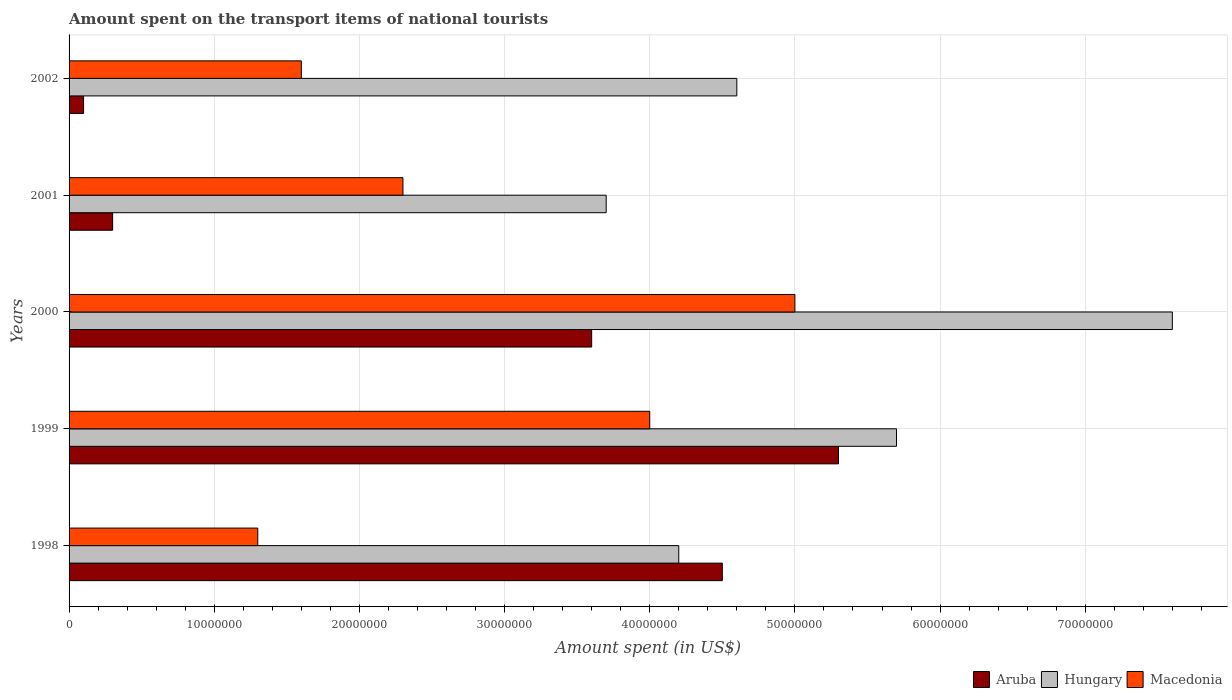How many bars are there on the 3rd tick from the top?
Your response must be concise. 3. How many bars are there on the 4th tick from the bottom?
Your answer should be compact. 3. What is the label of the 1st group of bars from the top?
Offer a terse response. 2002. In how many cases, is the number of bars for a given year not equal to the number of legend labels?
Offer a very short reply. 0. What is the amount spent on the transport items of national tourists in Macedonia in 1998?
Offer a very short reply. 1.30e+07. In which year was the amount spent on the transport items of national tourists in Aruba maximum?
Your response must be concise. 1999. What is the total amount spent on the transport items of national tourists in Aruba in the graph?
Offer a terse response. 1.38e+08. What is the average amount spent on the transport items of national tourists in Hungary per year?
Your answer should be compact. 5.16e+07. In the year 2001, what is the difference between the amount spent on the transport items of national tourists in Aruba and amount spent on the transport items of national tourists in Hungary?
Keep it short and to the point. -3.40e+07. In how many years, is the amount spent on the transport items of national tourists in Aruba greater than 52000000 US$?
Your answer should be very brief. 1. What is the ratio of the amount spent on the transport items of national tourists in Hungary in 1999 to that in 2000?
Offer a terse response. 0.75. Is the difference between the amount spent on the transport items of national tourists in Aruba in 1998 and 2001 greater than the difference between the amount spent on the transport items of national tourists in Hungary in 1998 and 2001?
Provide a short and direct response. Yes. What is the difference between the highest and the lowest amount spent on the transport items of national tourists in Hungary?
Your answer should be compact. 3.90e+07. In how many years, is the amount spent on the transport items of national tourists in Hungary greater than the average amount spent on the transport items of national tourists in Hungary taken over all years?
Make the answer very short. 2. Is the sum of the amount spent on the transport items of national tourists in Macedonia in 1998 and 2000 greater than the maximum amount spent on the transport items of national tourists in Aruba across all years?
Offer a very short reply. Yes. What does the 3rd bar from the top in 2001 represents?
Your answer should be very brief. Aruba. What does the 1st bar from the bottom in 2002 represents?
Offer a terse response. Aruba. How many bars are there?
Your answer should be very brief. 15. Does the graph contain grids?
Ensure brevity in your answer.  Yes. Where does the legend appear in the graph?
Your answer should be compact. Bottom right. How many legend labels are there?
Your response must be concise. 3. What is the title of the graph?
Give a very brief answer. Amount spent on the transport items of national tourists. Does "Grenada" appear as one of the legend labels in the graph?
Provide a succinct answer. No. What is the label or title of the X-axis?
Ensure brevity in your answer.  Amount spent (in US$). What is the label or title of the Y-axis?
Ensure brevity in your answer.  Years. What is the Amount spent (in US$) in Aruba in 1998?
Keep it short and to the point. 4.50e+07. What is the Amount spent (in US$) of Hungary in 1998?
Your response must be concise. 4.20e+07. What is the Amount spent (in US$) in Macedonia in 1998?
Your answer should be compact. 1.30e+07. What is the Amount spent (in US$) in Aruba in 1999?
Make the answer very short. 5.30e+07. What is the Amount spent (in US$) in Hungary in 1999?
Provide a succinct answer. 5.70e+07. What is the Amount spent (in US$) of Macedonia in 1999?
Offer a terse response. 4.00e+07. What is the Amount spent (in US$) of Aruba in 2000?
Offer a terse response. 3.60e+07. What is the Amount spent (in US$) of Hungary in 2000?
Make the answer very short. 7.60e+07. What is the Amount spent (in US$) of Macedonia in 2000?
Provide a succinct answer. 5.00e+07. What is the Amount spent (in US$) in Hungary in 2001?
Keep it short and to the point. 3.70e+07. What is the Amount spent (in US$) of Macedonia in 2001?
Give a very brief answer. 2.30e+07. What is the Amount spent (in US$) of Aruba in 2002?
Make the answer very short. 1.00e+06. What is the Amount spent (in US$) of Hungary in 2002?
Give a very brief answer. 4.60e+07. What is the Amount spent (in US$) of Macedonia in 2002?
Make the answer very short. 1.60e+07. Across all years, what is the maximum Amount spent (in US$) in Aruba?
Provide a short and direct response. 5.30e+07. Across all years, what is the maximum Amount spent (in US$) in Hungary?
Make the answer very short. 7.60e+07. Across all years, what is the maximum Amount spent (in US$) in Macedonia?
Keep it short and to the point. 5.00e+07. Across all years, what is the minimum Amount spent (in US$) of Aruba?
Your answer should be very brief. 1.00e+06. Across all years, what is the minimum Amount spent (in US$) of Hungary?
Your answer should be compact. 3.70e+07. Across all years, what is the minimum Amount spent (in US$) of Macedonia?
Make the answer very short. 1.30e+07. What is the total Amount spent (in US$) of Aruba in the graph?
Offer a very short reply. 1.38e+08. What is the total Amount spent (in US$) of Hungary in the graph?
Keep it short and to the point. 2.58e+08. What is the total Amount spent (in US$) of Macedonia in the graph?
Your response must be concise. 1.42e+08. What is the difference between the Amount spent (in US$) in Aruba in 1998 and that in 1999?
Make the answer very short. -8.00e+06. What is the difference between the Amount spent (in US$) in Hungary in 1998 and that in 1999?
Provide a short and direct response. -1.50e+07. What is the difference between the Amount spent (in US$) in Macedonia in 1998 and that in 1999?
Your response must be concise. -2.70e+07. What is the difference between the Amount spent (in US$) in Aruba in 1998 and that in 2000?
Offer a very short reply. 9.00e+06. What is the difference between the Amount spent (in US$) of Hungary in 1998 and that in 2000?
Offer a terse response. -3.40e+07. What is the difference between the Amount spent (in US$) in Macedonia in 1998 and that in 2000?
Your answer should be compact. -3.70e+07. What is the difference between the Amount spent (in US$) in Aruba in 1998 and that in 2001?
Provide a succinct answer. 4.20e+07. What is the difference between the Amount spent (in US$) of Hungary in 1998 and that in 2001?
Offer a terse response. 5.00e+06. What is the difference between the Amount spent (in US$) of Macedonia in 1998 and that in 2001?
Give a very brief answer. -1.00e+07. What is the difference between the Amount spent (in US$) of Aruba in 1998 and that in 2002?
Make the answer very short. 4.40e+07. What is the difference between the Amount spent (in US$) of Hungary in 1998 and that in 2002?
Offer a very short reply. -4.00e+06. What is the difference between the Amount spent (in US$) in Aruba in 1999 and that in 2000?
Make the answer very short. 1.70e+07. What is the difference between the Amount spent (in US$) in Hungary in 1999 and that in 2000?
Provide a succinct answer. -1.90e+07. What is the difference between the Amount spent (in US$) in Macedonia in 1999 and that in 2000?
Offer a terse response. -1.00e+07. What is the difference between the Amount spent (in US$) of Hungary in 1999 and that in 2001?
Your answer should be very brief. 2.00e+07. What is the difference between the Amount spent (in US$) in Macedonia in 1999 and that in 2001?
Give a very brief answer. 1.70e+07. What is the difference between the Amount spent (in US$) of Aruba in 1999 and that in 2002?
Your answer should be very brief. 5.20e+07. What is the difference between the Amount spent (in US$) in Hungary in 1999 and that in 2002?
Make the answer very short. 1.10e+07. What is the difference between the Amount spent (in US$) of Macedonia in 1999 and that in 2002?
Make the answer very short. 2.40e+07. What is the difference between the Amount spent (in US$) of Aruba in 2000 and that in 2001?
Provide a short and direct response. 3.30e+07. What is the difference between the Amount spent (in US$) in Hungary in 2000 and that in 2001?
Your answer should be compact. 3.90e+07. What is the difference between the Amount spent (in US$) of Macedonia in 2000 and that in 2001?
Your answer should be compact. 2.70e+07. What is the difference between the Amount spent (in US$) of Aruba in 2000 and that in 2002?
Provide a short and direct response. 3.50e+07. What is the difference between the Amount spent (in US$) of Hungary in 2000 and that in 2002?
Offer a terse response. 3.00e+07. What is the difference between the Amount spent (in US$) of Macedonia in 2000 and that in 2002?
Provide a short and direct response. 3.40e+07. What is the difference between the Amount spent (in US$) of Hungary in 2001 and that in 2002?
Keep it short and to the point. -9.00e+06. What is the difference between the Amount spent (in US$) of Macedonia in 2001 and that in 2002?
Provide a short and direct response. 7.00e+06. What is the difference between the Amount spent (in US$) in Aruba in 1998 and the Amount spent (in US$) in Hungary in 1999?
Keep it short and to the point. -1.20e+07. What is the difference between the Amount spent (in US$) in Hungary in 1998 and the Amount spent (in US$) in Macedonia in 1999?
Your response must be concise. 2.00e+06. What is the difference between the Amount spent (in US$) in Aruba in 1998 and the Amount spent (in US$) in Hungary in 2000?
Offer a terse response. -3.10e+07. What is the difference between the Amount spent (in US$) in Aruba in 1998 and the Amount spent (in US$) in Macedonia in 2000?
Provide a short and direct response. -5.00e+06. What is the difference between the Amount spent (in US$) of Hungary in 1998 and the Amount spent (in US$) of Macedonia in 2000?
Give a very brief answer. -8.00e+06. What is the difference between the Amount spent (in US$) in Aruba in 1998 and the Amount spent (in US$) in Hungary in 2001?
Your answer should be compact. 8.00e+06. What is the difference between the Amount spent (in US$) of Aruba in 1998 and the Amount spent (in US$) of Macedonia in 2001?
Offer a very short reply. 2.20e+07. What is the difference between the Amount spent (in US$) of Hungary in 1998 and the Amount spent (in US$) of Macedonia in 2001?
Offer a very short reply. 1.90e+07. What is the difference between the Amount spent (in US$) of Aruba in 1998 and the Amount spent (in US$) of Hungary in 2002?
Make the answer very short. -1.00e+06. What is the difference between the Amount spent (in US$) of Aruba in 1998 and the Amount spent (in US$) of Macedonia in 2002?
Offer a terse response. 2.90e+07. What is the difference between the Amount spent (in US$) of Hungary in 1998 and the Amount spent (in US$) of Macedonia in 2002?
Keep it short and to the point. 2.60e+07. What is the difference between the Amount spent (in US$) of Aruba in 1999 and the Amount spent (in US$) of Hungary in 2000?
Your answer should be very brief. -2.30e+07. What is the difference between the Amount spent (in US$) in Aruba in 1999 and the Amount spent (in US$) in Hungary in 2001?
Ensure brevity in your answer.  1.60e+07. What is the difference between the Amount spent (in US$) of Aruba in 1999 and the Amount spent (in US$) of Macedonia in 2001?
Keep it short and to the point. 3.00e+07. What is the difference between the Amount spent (in US$) in Hungary in 1999 and the Amount spent (in US$) in Macedonia in 2001?
Keep it short and to the point. 3.40e+07. What is the difference between the Amount spent (in US$) of Aruba in 1999 and the Amount spent (in US$) of Macedonia in 2002?
Your response must be concise. 3.70e+07. What is the difference between the Amount spent (in US$) in Hungary in 1999 and the Amount spent (in US$) in Macedonia in 2002?
Your answer should be very brief. 4.10e+07. What is the difference between the Amount spent (in US$) in Aruba in 2000 and the Amount spent (in US$) in Macedonia in 2001?
Ensure brevity in your answer.  1.30e+07. What is the difference between the Amount spent (in US$) of Hungary in 2000 and the Amount spent (in US$) of Macedonia in 2001?
Make the answer very short. 5.30e+07. What is the difference between the Amount spent (in US$) in Aruba in 2000 and the Amount spent (in US$) in Hungary in 2002?
Offer a very short reply. -1.00e+07. What is the difference between the Amount spent (in US$) of Hungary in 2000 and the Amount spent (in US$) of Macedonia in 2002?
Your response must be concise. 6.00e+07. What is the difference between the Amount spent (in US$) of Aruba in 2001 and the Amount spent (in US$) of Hungary in 2002?
Your answer should be very brief. -4.30e+07. What is the difference between the Amount spent (in US$) of Aruba in 2001 and the Amount spent (in US$) of Macedonia in 2002?
Offer a very short reply. -1.30e+07. What is the difference between the Amount spent (in US$) of Hungary in 2001 and the Amount spent (in US$) of Macedonia in 2002?
Offer a terse response. 2.10e+07. What is the average Amount spent (in US$) in Aruba per year?
Your answer should be very brief. 2.76e+07. What is the average Amount spent (in US$) of Hungary per year?
Provide a succinct answer. 5.16e+07. What is the average Amount spent (in US$) of Macedonia per year?
Your answer should be compact. 2.84e+07. In the year 1998, what is the difference between the Amount spent (in US$) of Aruba and Amount spent (in US$) of Hungary?
Your response must be concise. 3.00e+06. In the year 1998, what is the difference between the Amount spent (in US$) of Aruba and Amount spent (in US$) of Macedonia?
Provide a short and direct response. 3.20e+07. In the year 1998, what is the difference between the Amount spent (in US$) of Hungary and Amount spent (in US$) of Macedonia?
Keep it short and to the point. 2.90e+07. In the year 1999, what is the difference between the Amount spent (in US$) in Aruba and Amount spent (in US$) in Macedonia?
Keep it short and to the point. 1.30e+07. In the year 1999, what is the difference between the Amount spent (in US$) in Hungary and Amount spent (in US$) in Macedonia?
Keep it short and to the point. 1.70e+07. In the year 2000, what is the difference between the Amount spent (in US$) in Aruba and Amount spent (in US$) in Hungary?
Provide a succinct answer. -4.00e+07. In the year 2000, what is the difference between the Amount spent (in US$) of Aruba and Amount spent (in US$) of Macedonia?
Your answer should be compact. -1.40e+07. In the year 2000, what is the difference between the Amount spent (in US$) of Hungary and Amount spent (in US$) of Macedonia?
Provide a succinct answer. 2.60e+07. In the year 2001, what is the difference between the Amount spent (in US$) in Aruba and Amount spent (in US$) in Hungary?
Offer a very short reply. -3.40e+07. In the year 2001, what is the difference between the Amount spent (in US$) of Aruba and Amount spent (in US$) of Macedonia?
Give a very brief answer. -2.00e+07. In the year 2001, what is the difference between the Amount spent (in US$) of Hungary and Amount spent (in US$) of Macedonia?
Ensure brevity in your answer.  1.40e+07. In the year 2002, what is the difference between the Amount spent (in US$) in Aruba and Amount spent (in US$) in Hungary?
Keep it short and to the point. -4.50e+07. In the year 2002, what is the difference between the Amount spent (in US$) in Aruba and Amount spent (in US$) in Macedonia?
Offer a very short reply. -1.50e+07. In the year 2002, what is the difference between the Amount spent (in US$) in Hungary and Amount spent (in US$) in Macedonia?
Your answer should be compact. 3.00e+07. What is the ratio of the Amount spent (in US$) in Aruba in 1998 to that in 1999?
Make the answer very short. 0.85. What is the ratio of the Amount spent (in US$) of Hungary in 1998 to that in 1999?
Keep it short and to the point. 0.74. What is the ratio of the Amount spent (in US$) in Macedonia in 1998 to that in 1999?
Offer a terse response. 0.33. What is the ratio of the Amount spent (in US$) of Hungary in 1998 to that in 2000?
Offer a terse response. 0.55. What is the ratio of the Amount spent (in US$) in Macedonia in 1998 to that in 2000?
Give a very brief answer. 0.26. What is the ratio of the Amount spent (in US$) of Hungary in 1998 to that in 2001?
Your answer should be compact. 1.14. What is the ratio of the Amount spent (in US$) of Macedonia in 1998 to that in 2001?
Your answer should be compact. 0.57. What is the ratio of the Amount spent (in US$) in Macedonia in 1998 to that in 2002?
Offer a terse response. 0.81. What is the ratio of the Amount spent (in US$) in Aruba in 1999 to that in 2000?
Your answer should be very brief. 1.47. What is the ratio of the Amount spent (in US$) in Macedonia in 1999 to that in 2000?
Your answer should be very brief. 0.8. What is the ratio of the Amount spent (in US$) of Aruba in 1999 to that in 2001?
Offer a terse response. 17.67. What is the ratio of the Amount spent (in US$) of Hungary in 1999 to that in 2001?
Your answer should be very brief. 1.54. What is the ratio of the Amount spent (in US$) of Macedonia in 1999 to that in 2001?
Your response must be concise. 1.74. What is the ratio of the Amount spent (in US$) of Aruba in 1999 to that in 2002?
Keep it short and to the point. 53. What is the ratio of the Amount spent (in US$) of Hungary in 1999 to that in 2002?
Give a very brief answer. 1.24. What is the ratio of the Amount spent (in US$) in Hungary in 2000 to that in 2001?
Your response must be concise. 2.05. What is the ratio of the Amount spent (in US$) of Macedonia in 2000 to that in 2001?
Provide a short and direct response. 2.17. What is the ratio of the Amount spent (in US$) of Aruba in 2000 to that in 2002?
Give a very brief answer. 36. What is the ratio of the Amount spent (in US$) of Hungary in 2000 to that in 2002?
Your response must be concise. 1.65. What is the ratio of the Amount spent (in US$) of Macedonia in 2000 to that in 2002?
Your answer should be very brief. 3.12. What is the ratio of the Amount spent (in US$) of Hungary in 2001 to that in 2002?
Offer a very short reply. 0.8. What is the ratio of the Amount spent (in US$) in Macedonia in 2001 to that in 2002?
Provide a succinct answer. 1.44. What is the difference between the highest and the second highest Amount spent (in US$) of Aruba?
Offer a terse response. 8.00e+06. What is the difference between the highest and the second highest Amount spent (in US$) in Hungary?
Offer a terse response. 1.90e+07. What is the difference between the highest and the second highest Amount spent (in US$) in Macedonia?
Keep it short and to the point. 1.00e+07. What is the difference between the highest and the lowest Amount spent (in US$) in Aruba?
Your answer should be very brief. 5.20e+07. What is the difference between the highest and the lowest Amount spent (in US$) in Hungary?
Make the answer very short. 3.90e+07. What is the difference between the highest and the lowest Amount spent (in US$) of Macedonia?
Keep it short and to the point. 3.70e+07. 